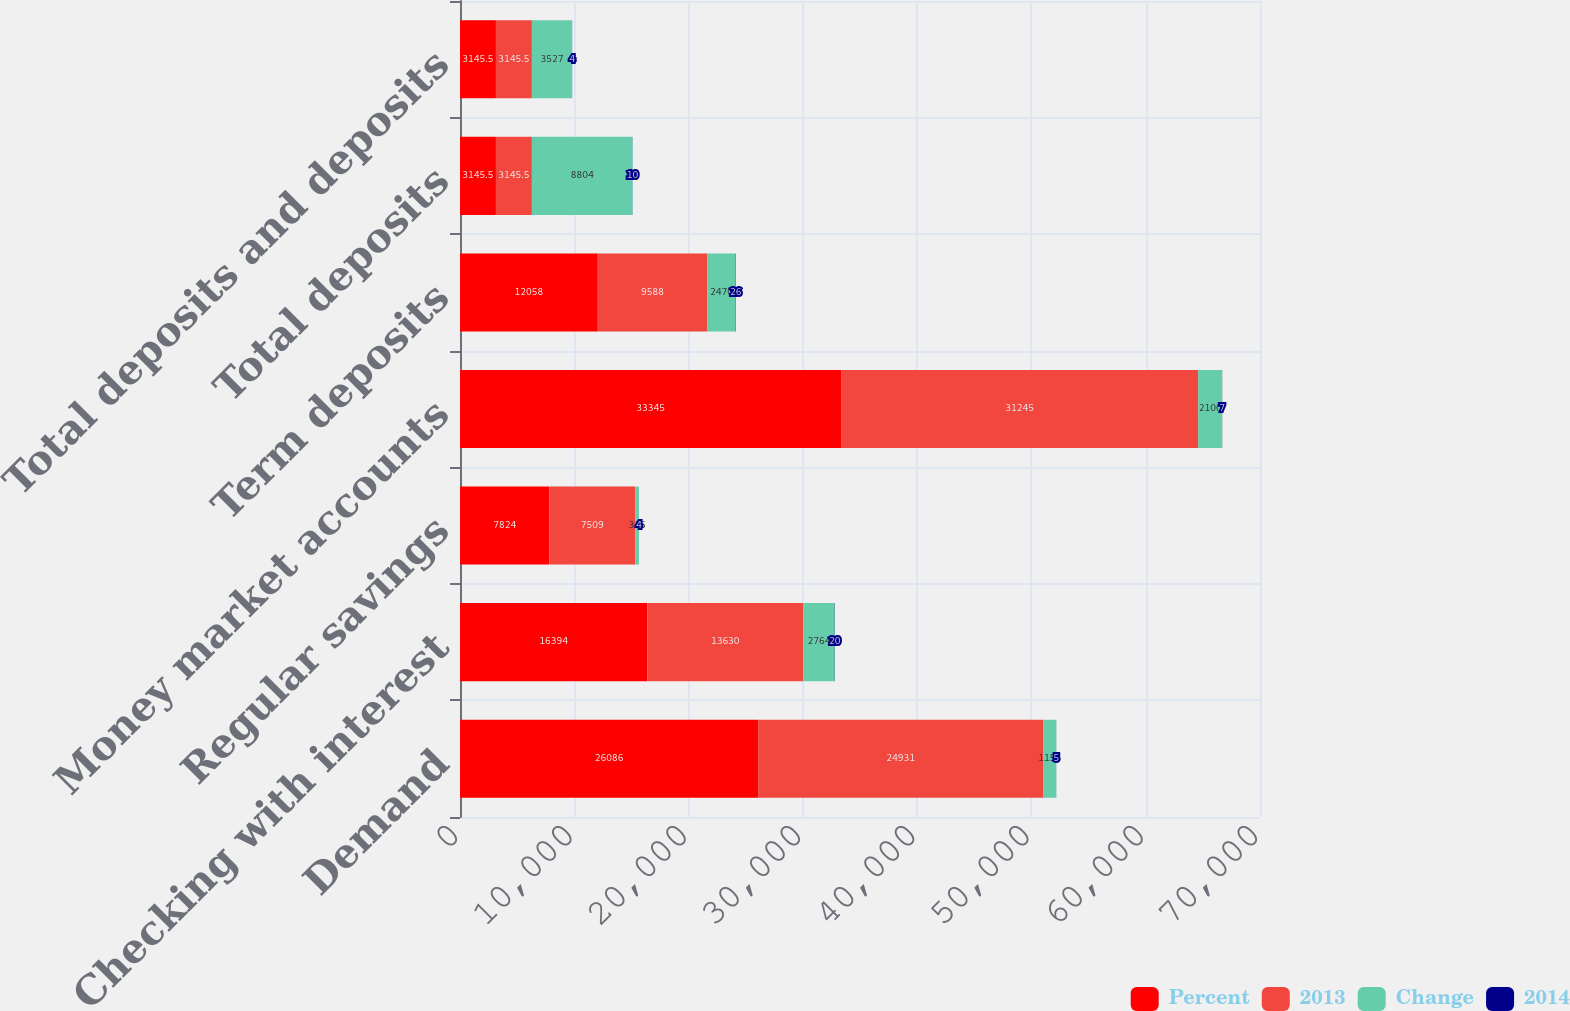Convert chart to OTSL. <chart><loc_0><loc_0><loc_500><loc_500><stacked_bar_chart><ecel><fcel>Demand<fcel>Checking with interest<fcel>Regular savings<fcel>Money market accounts<fcel>Term deposits<fcel>Total deposits<fcel>Total deposits and deposits<nl><fcel>Percent<fcel>26086<fcel>16394<fcel>7824<fcel>33345<fcel>12058<fcel>3145.5<fcel>3145.5<nl><fcel>2013<fcel>24931<fcel>13630<fcel>7509<fcel>31245<fcel>9588<fcel>3145.5<fcel>3145.5<nl><fcel>Change<fcel>1155<fcel>2764<fcel>315<fcel>2100<fcel>2470<fcel>8804<fcel>3527<nl><fcel>2014<fcel>5<fcel>20<fcel>4<fcel>7<fcel>26<fcel>10<fcel>4<nl></chart> 